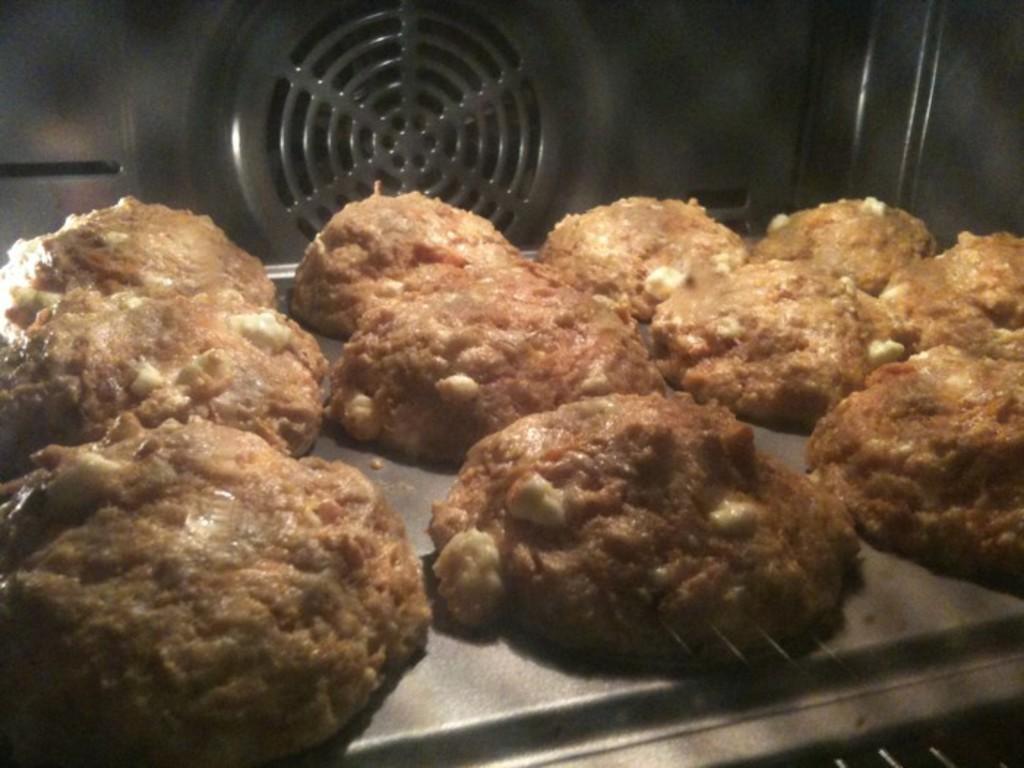How would you summarize this image in a sentence or two? In this image we can see cookies placed in the oven. 